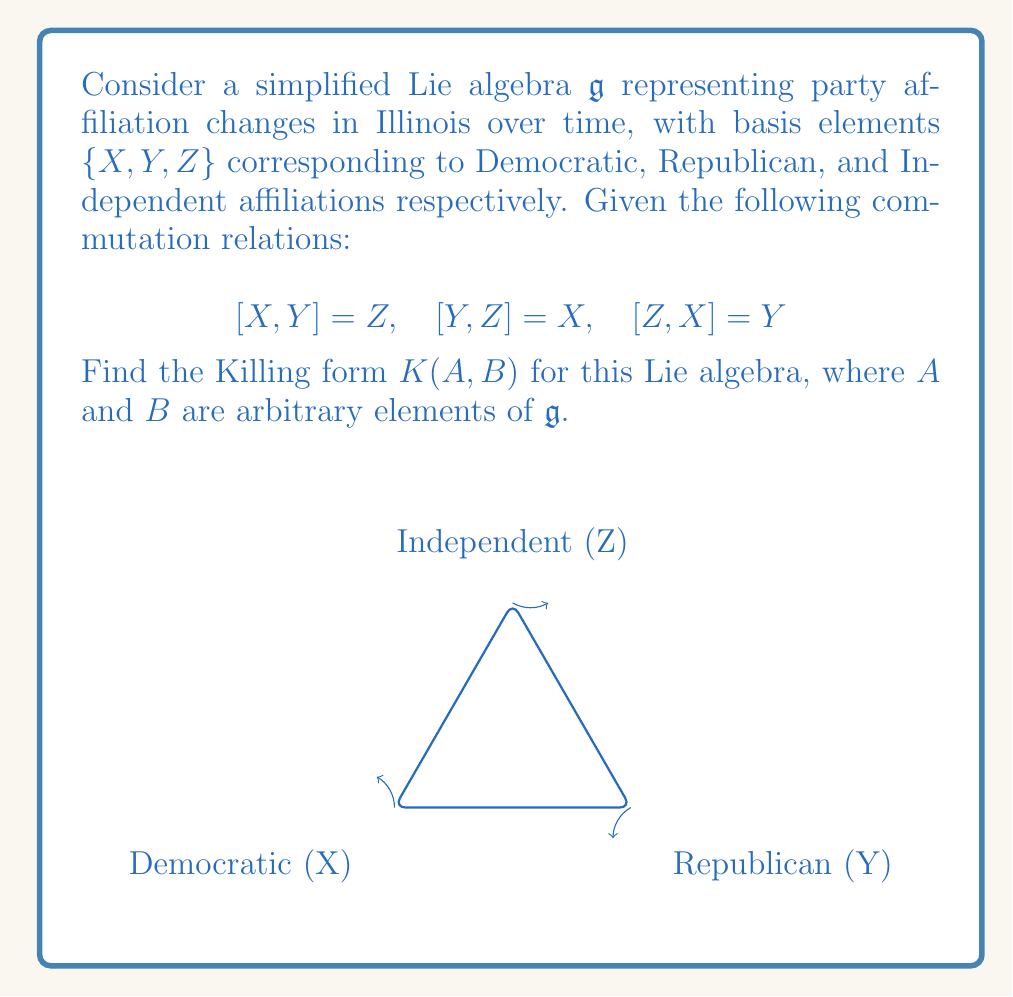Can you answer this question? To find the Killing form, we follow these steps:

1) The Killing form is defined as $K(A,B) = \text{tr}(\text{ad}_A \circ \text{ad}_B)$, where $\text{ad}_X$ is the adjoint representation of $X$.

2) First, we need to find the matrix representations of $\text{ad}_X$, $\text{ad}_Y$, and $\text{ad}_Z$:

   $\text{ad}_X = \begin{pmatrix} 0 & 0 & -1 \\ 0 & 0 & 1 \\ 0 & -1 & 0 \end{pmatrix}$

   $\text{ad}_Y = \begin{pmatrix} 0 & 0 & 1 \\ 0 & 0 & -1 \\ -1 & 0 & 0 \end{pmatrix}$

   $\text{ad}_Z = \begin{pmatrix} 0 & -1 & 0 \\ 1 & 0 & 0 \\ 0 & 0 & 0 \end{pmatrix}$

3) Now, let $A = aX + bY + cZ$ and $B = dX + eY + fZ$ be arbitrary elements of $\mathfrak{g}$.

4) We compute $\text{ad}_A = a\text{ad}_X + b\text{ad}_Y + c\text{ad}_Z$:

   $\text{ad}_A = \begin{pmatrix} 0 & -c & -a \\ c & 0 & b \\ -b & -a & 0 \end{pmatrix}$

5) Similarly, $\text{ad}_B = d\text{ad}_X + e\text{ad}_Y + f\text{ad}_Z$:

   $\text{ad}_B = \begin{pmatrix} 0 & -f & -d \\ f & 0 & e \\ -e & -d & 0 \end{pmatrix}$

6) We calculate $\text{ad}_A \circ \text{ad}_B$:

   $\text{ad}_A \circ \text{ad}_B = \begin{pmatrix} -ae-bf & -af+bd & -ad+be \\ af-cd & -bd-cf & -be+ca \\ cd-bf & ce+ad & -ae-bf \end{pmatrix}$

7) The trace of this matrix is $-2(ae+bf+cd)$.

8) Therefore, the Killing form is $K(A,B) = -2(ae+bf+cd)$.
Answer: $K(A,B) = -2(ae+bf+cd)$ 